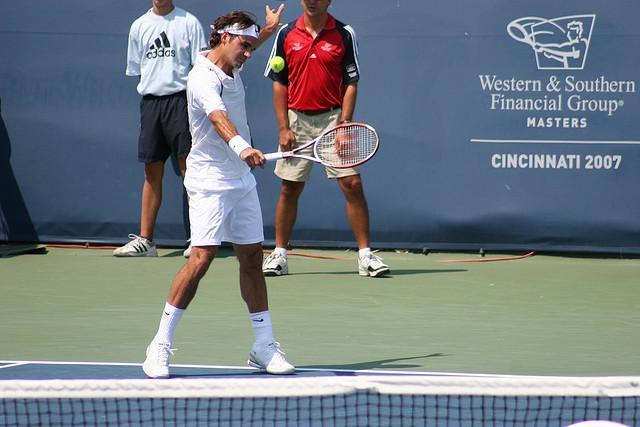How many people can be seen?
Give a very brief answer. 3. 